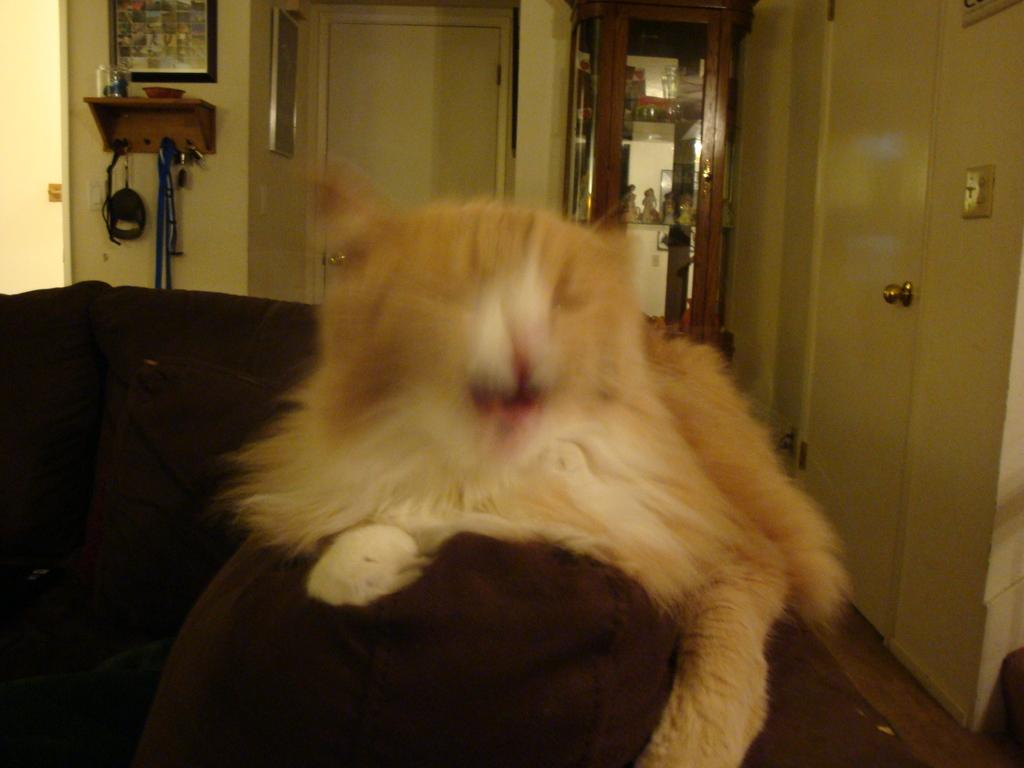What animal can be seen on the sofa in the image? There is a cat on the sofa in the image. What objects can be seen in the background of the image? There are bottles, doors, frames on the wall, and things in the racks in the background of the image. What type of weather can be seen in the image? The image does not depict any weather conditions; it is an indoor scene with a cat on a sofa and various objects in the background. 